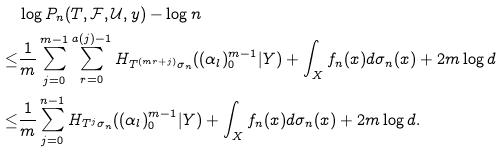Convert formula to latex. <formula><loc_0><loc_0><loc_500><loc_500>& \log P _ { n } ( T , \mathcal { F } , \mathcal { U } , y ) - \log n \\ \leq & \frac { 1 } { m } \sum _ { j = 0 } ^ { m - 1 } \sum _ { r = 0 } ^ { a ( j ) - 1 } H _ { T ^ { ( m r + j ) } \sigma _ { n } } ( ( \alpha _ { l } ) ^ { m - 1 } _ { 0 } | Y ) + \int _ { X } f _ { n } ( x ) d \sigma _ { n } ( x ) + 2 m \log d \\ \leq & \frac { 1 } { m } \sum _ { j = 0 } ^ { n - 1 } H _ { T ^ { j } \sigma _ { n } } ( ( \alpha _ { l } ) ^ { m - 1 } _ { 0 } | Y ) + \int _ { X } f _ { n } ( x ) d \sigma _ { n } ( x ) + 2 m \log d .</formula> 